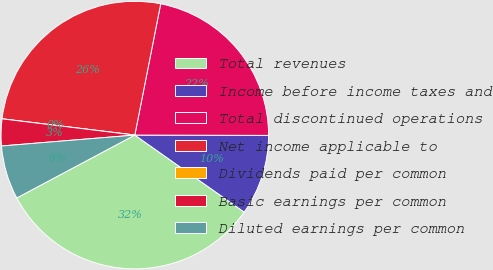<chart> <loc_0><loc_0><loc_500><loc_500><pie_chart><fcel>Total revenues<fcel>Income before income taxes and<fcel>Total discontinued operations<fcel>Net income applicable to<fcel>Dividends paid per common<fcel>Basic earnings per common<fcel>Diluted earnings per common<nl><fcel>32.44%<fcel>9.73%<fcel>21.94%<fcel>26.16%<fcel>0.0%<fcel>3.24%<fcel>6.49%<nl></chart> 